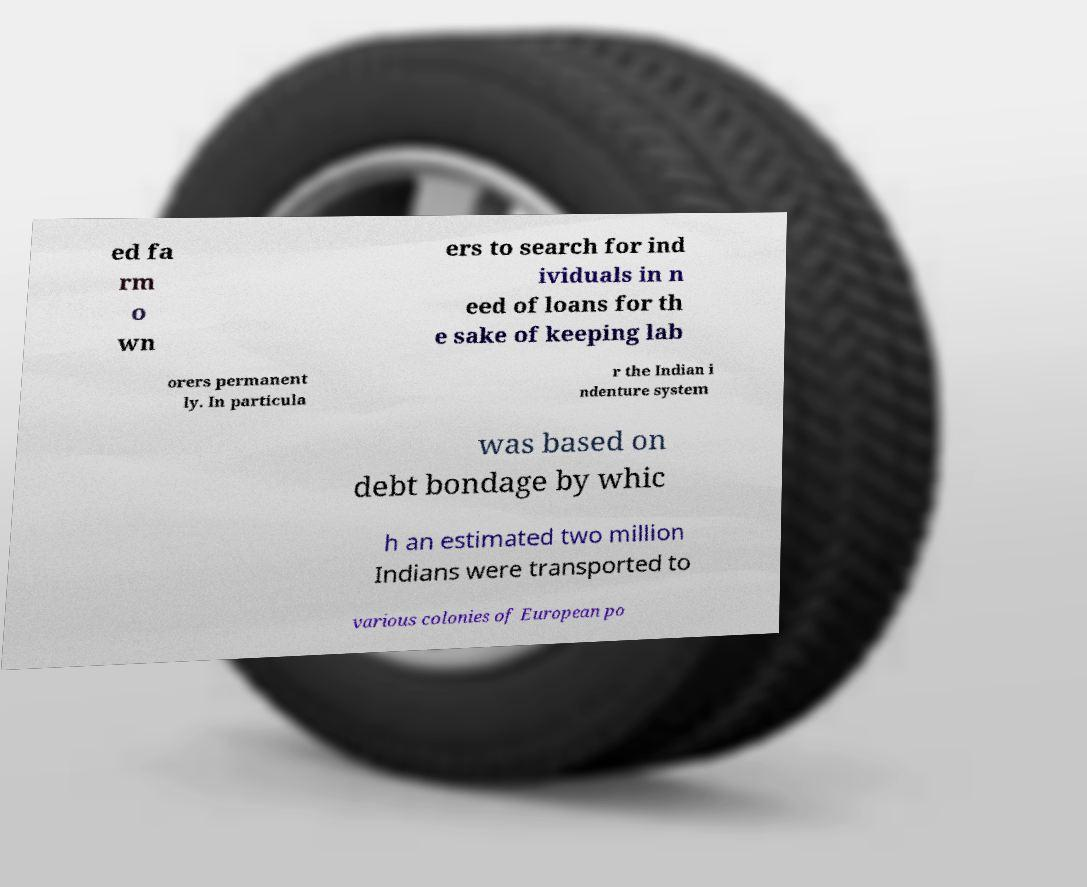Please read and relay the text visible in this image. What does it say? ed fa rm o wn ers to search for ind ividuals in n eed of loans for th e sake of keeping lab orers permanent ly. In particula r the Indian i ndenture system was based on debt bondage by whic h an estimated two million Indians were transported to various colonies of European po 